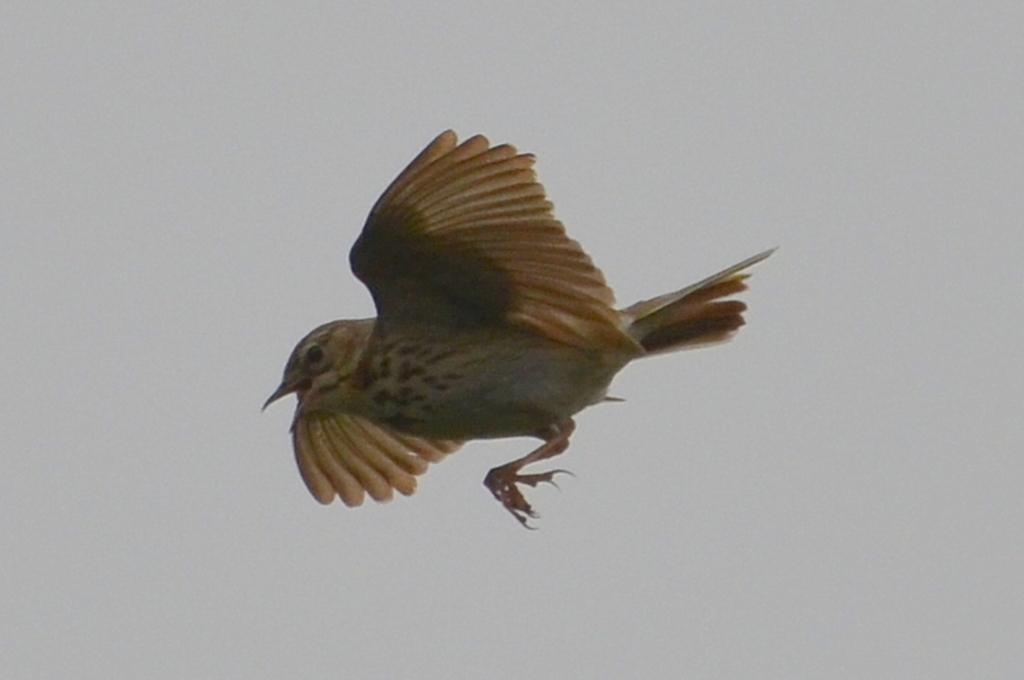Please provide a concise description of this image. In the picture I can see a bird is flying in the air. In the background I can see the sky. 